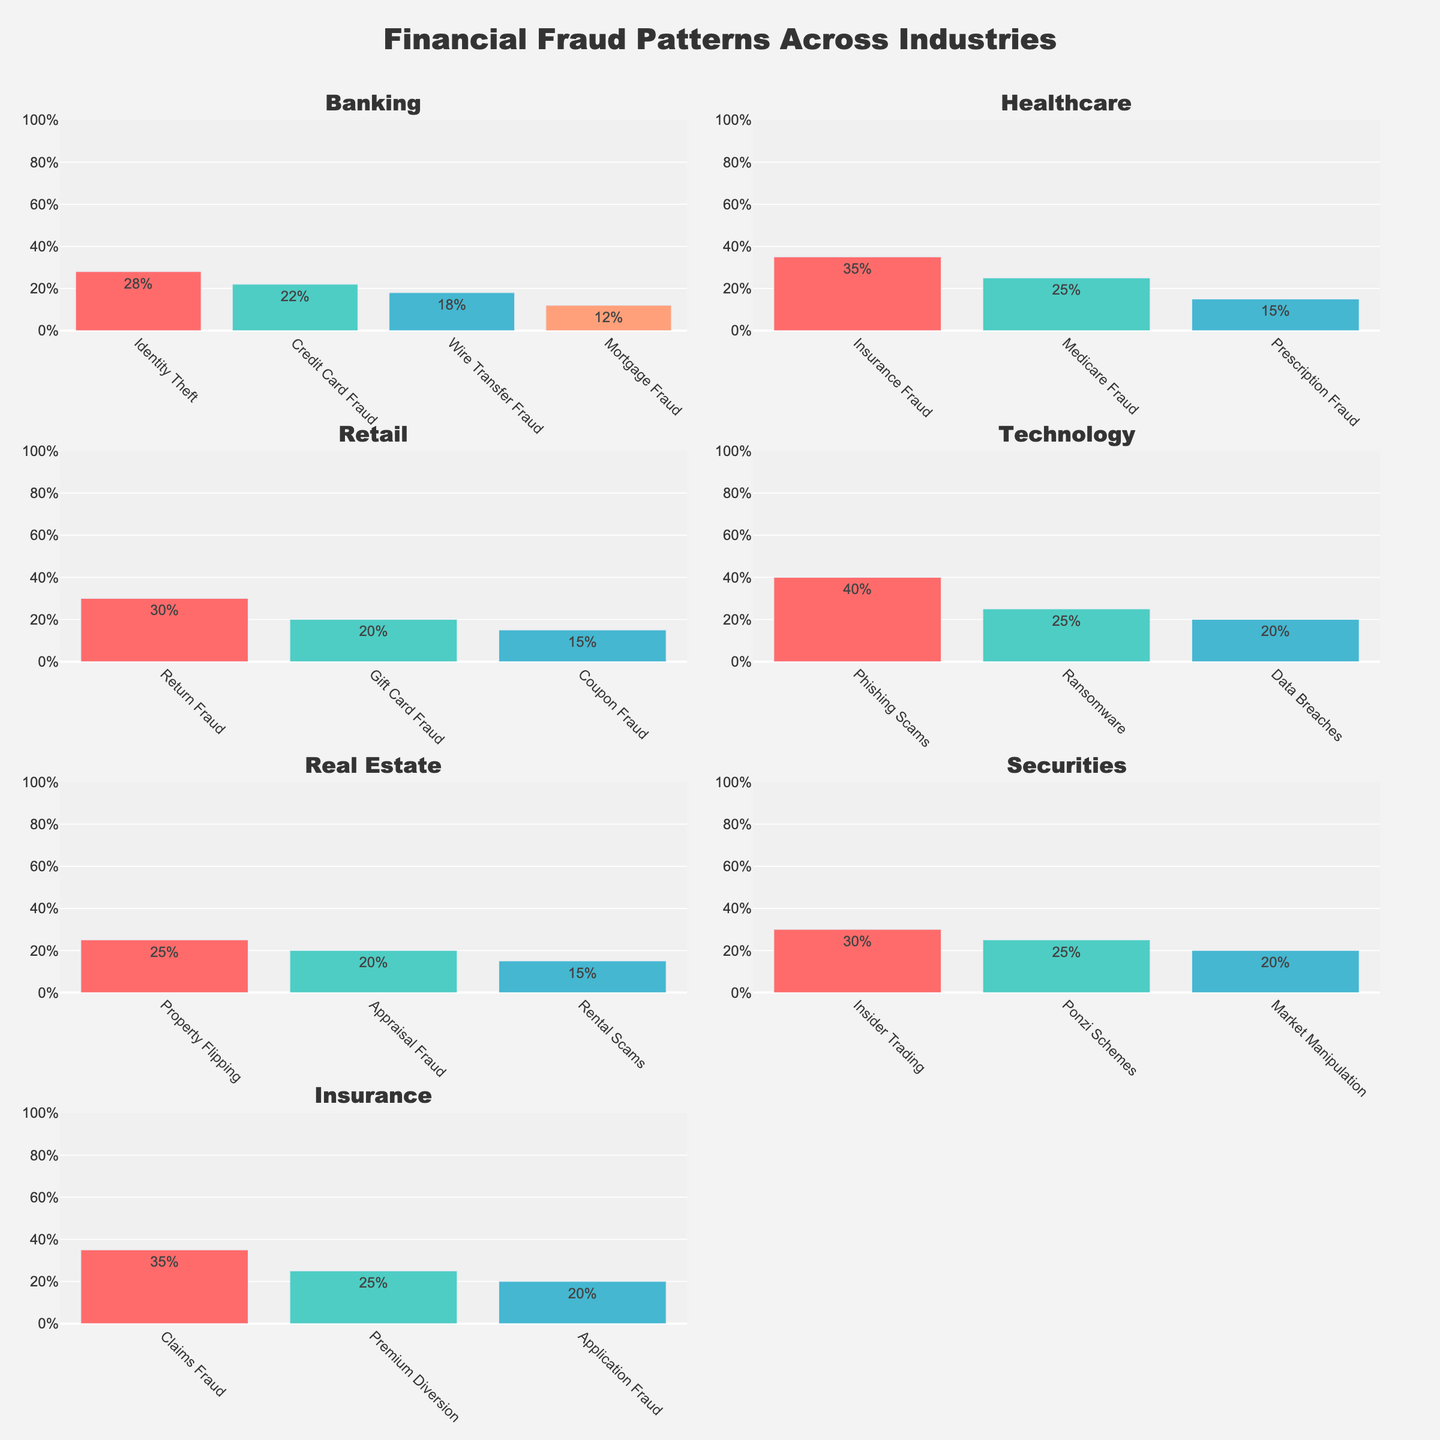What's the title of the figure? The title is prominently displayed at the top center of the figure and reads "Financial Fraud Patterns Across Industries".
Answer: Financial Fraud Patterns Across Industries What is the most common fraud type in the Banking industry? By examining the bar heights for the Banking industry subplot, the tallest bar represents Identity Theft with a percentage of 28%.
Answer: Identity Theft Which industry has the highest percentage of any fraud type, and what is that percentage? Looking across all subplots, the highest bar in any industry is in the Technology subplot for Phishing Scams with a percentage of 40%.
Answer: Technology, 40% In the Retail industry, what is the sum of the percentages for Return Fraud and Gift Card Fraud? In the Retail subplot, Return Fraud is 30% and Gift Card Fraud is 20%. Adding these together yields 30% + 20% = 50%.
Answer: 50% Compare the percentage of Phishing Scams in the Technology industry to Insider Trading in the Securities industry. Which one is higher and by how much? Phishing Scams in Technology is 40%, while Insider Trading in Securities is 30%. The difference between them is 40% - 30% = 10%.
Answer: Phishing Scams, 10% What is the least common fraud type in Real Estate, and what percentage does it represent? In the Real Estate subplot, the shortest bar corresponds to Rental Scams with a percentage of 15%.
Answer: Rental Scams, 15% What is the average percentage of fraud types in the Insurance industry? In the Insurance subplot, the percentages are 35% (Claims Fraud), 25% (Premium Diversion), and 20% (Application Fraud). Adding these gives 35% + 25% + 20% = 80%, and there are 3 types, so the average is 80% / 3 ≈ 26.67%.
Answer: 26.67% Which industry has the most diverse range of fraud types (i.e., the most number of different fraud types represented)? By checking each subplot for the number of fraud types listed, the Healthcare industry shows 4 different fraud types, making it the most diverse.
Answer: Healthcare If you combine the fraud percentages of Mortgage Fraud in Banking and Application Fraud in Insurance, what would the total be? Mortgage Fraud in Banking is 12%, and Application Fraud in Insurance is 20%. Adding these together yields 12% + 20% = 32%.
Answer: 32% 